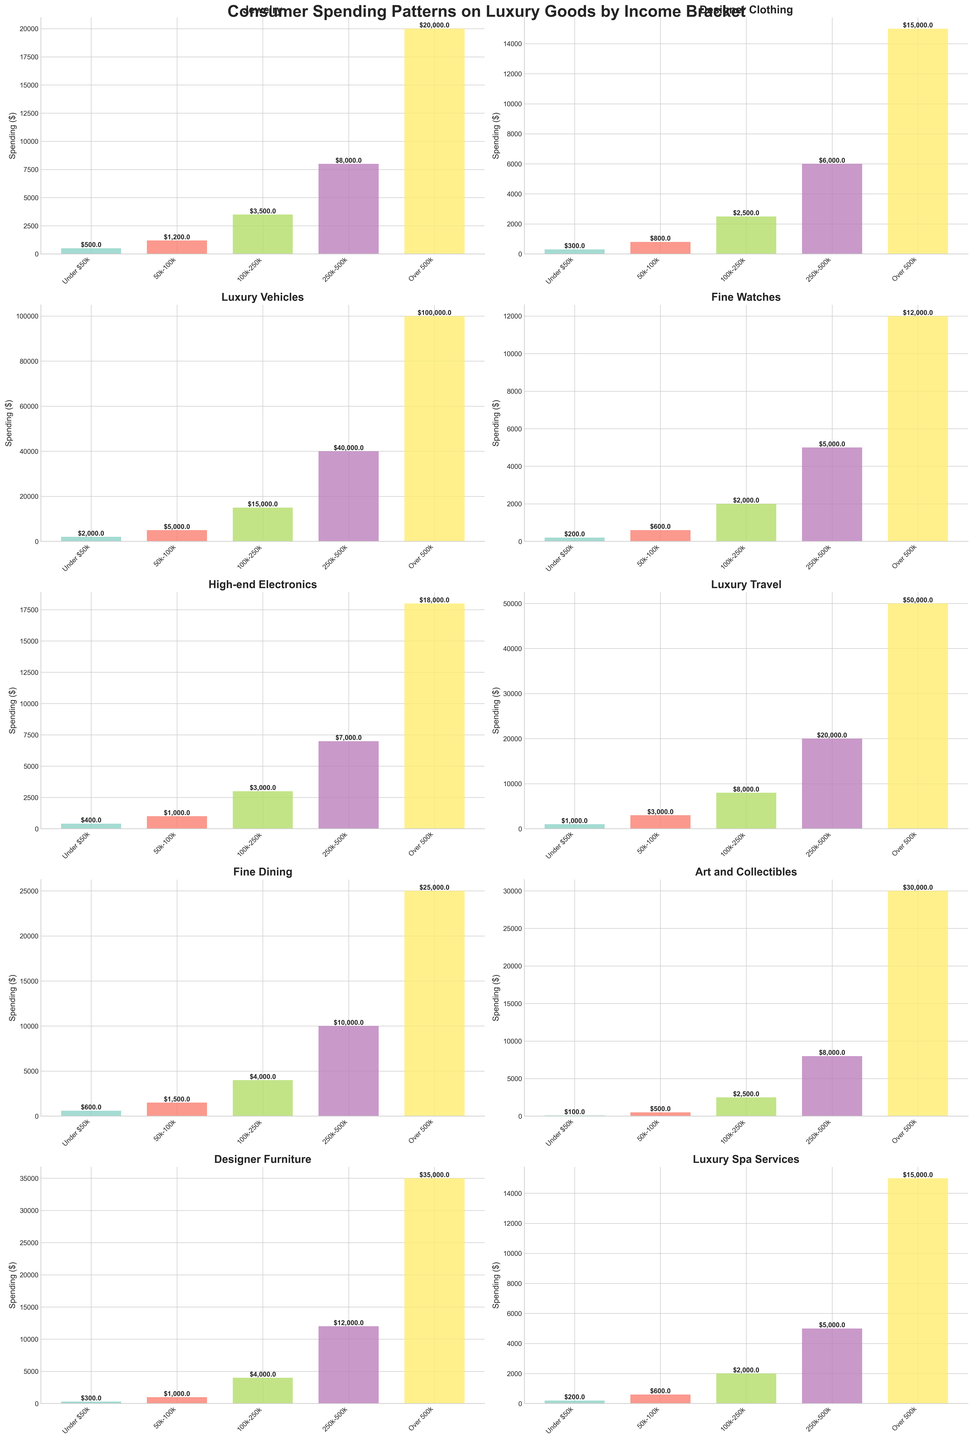Which income bracket spends the most on Luxury Vehicles? The height of the bars indicates spending levels. The bar representing the "Over 500k" income bracket is the tallest, indicating the highest spending in this category.
Answer: Over 500k Which category has the highest spending overall for the "Under $50k" income bracket? By comparing the heights of the bars in each subplot for the "Under $50k" category, the bar for "Luxury Vehicles" is the highest, indicating the highest spending.
Answer: Luxury Vehicles What is the total spending on Jewelry for all income brackets combined? Add the spending values for Jewelry from all income brackets: 500 + 1200 + 3500 + 8000 + 20000 = 33200
Answer: 33200 Which two categories show the largest difference in spending for the "100k-250k" income bracket? Compare the absolute differences between spending values for each pair of categories in the "100k-250k" income bracket. The largest difference is between "Luxury Vehicles" (15000) and "Art and Collectibles" (2500), which is 12500.
Answer: Luxury Vehicles and Art and Collectibles What is the average spending on Fine Dining for the income brackets "50k-100k" and "250k-500k"? Calculate the average by summing the spending for "Fine Dining" in "50k-100k" (1500) and "250k-500k" (10000) and then divide by 2: (1500 + 10000) / 2 = 5750
Answer: 5750 How does the spending on High-end Electronics in the "250k-500k" bracket compare to Designer Clothing in the "500k-100k" bracket? Compare the bar heights for these two categories: High-end Electronics in "250k-500k" has a spending of 7000, which is higher than Designer Clothing in "50k-100k" with a spending of 800.
Answer: Higher Which category shows the smallest spending difference between the "50k-100k" and "100k-250k" income brackets? Calculate the absolute differences for each category between these brackets: The smallest difference is for "Luxury Spa Services," where the difference is 2000 - 600 = 1400.
Answer: Luxury Spa Services Which income bracket has the lowest spending on Art and Collectibles? Identify the shortest bar in the "Art and Collectibles" subplot, which corresponds to the "Under $50k" income bracket with spending of 100.
Answer: Under $50k What is the overall trend in spending as the income bracket increases for Luxury Travel? Observe the bars for Luxury Travel across income brackets; the trend shows increasing spending for higher income brackets, peaking at the "Over 500k" with the highest bar.
Answer: Increases Which category shows the most significant increase in spending between the "250k-500k" and "Over 500k" brackets? Compare the differences in spending values: For "Art and Collectibles," the increase is the largest, from 8000 to 30000, a difference of 22000.
Answer: Art and Collectibles 